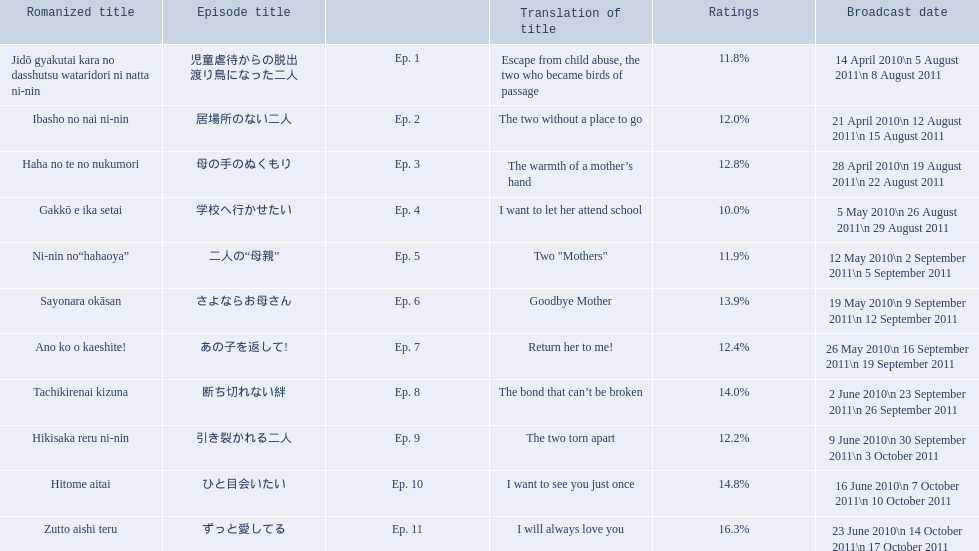Which episode had the highest ratings? Ep. 11. Which episode was named haha no te no nukumori? Ep. 3. Besides episode 10 which episode had a 14% rating? Ep. 8. 